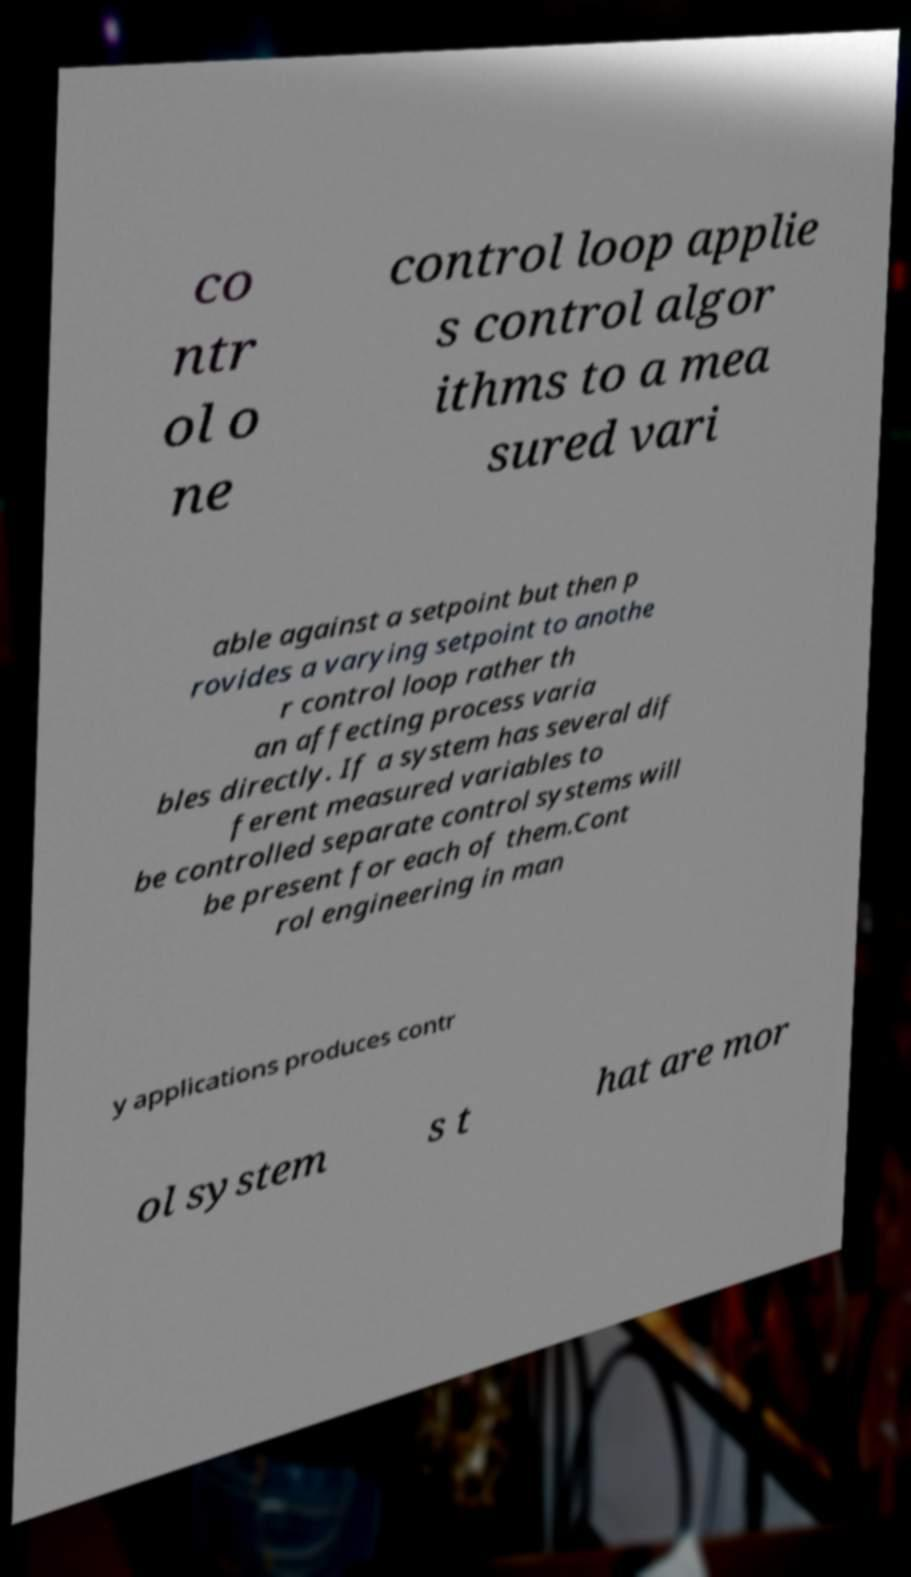Could you assist in decoding the text presented in this image and type it out clearly? co ntr ol o ne control loop applie s control algor ithms to a mea sured vari able against a setpoint but then p rovides a varying setpoint to anothe r control loop rather th an affecting process varia bles directly. If a system has several dif ferent measured variables to be controlled separate control systems will be present for each of them.Cont rol engineering in man y applications produces contr ol system s t hat are mor 